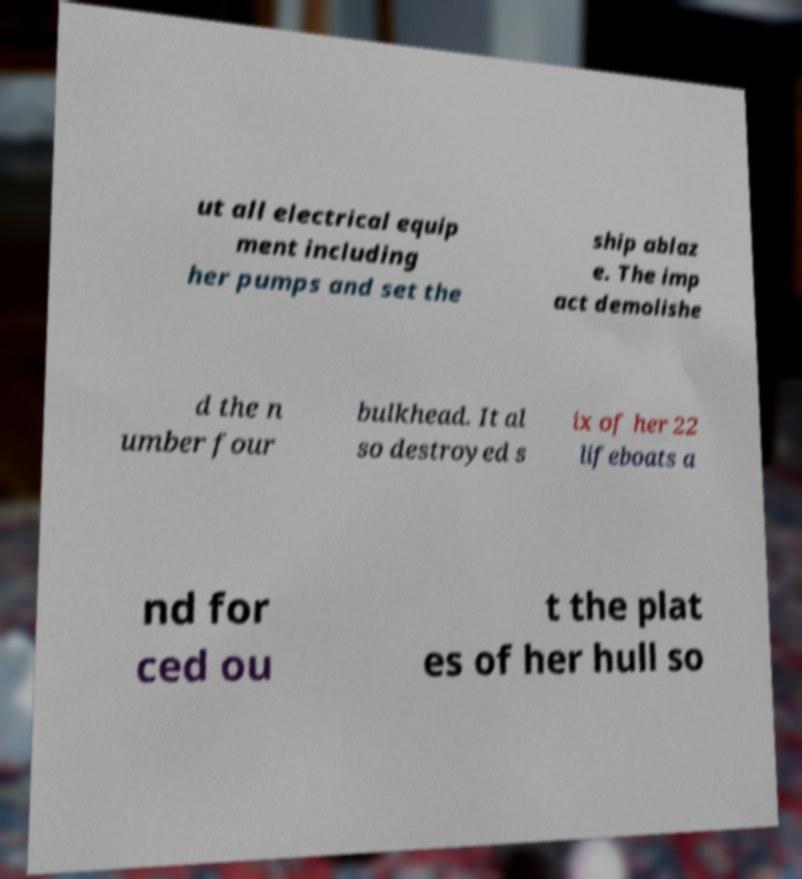Can you read and provide the text displayed in the image?This photo seems to have some interesting text. Can you extract and type it out for me? ut all electrical equip ment including her pumps and set the ship ablaz e. The imp act demolishe d the n umber four bulkhead. It al so destroyed s ix of her 22 lifeboats a nd for ced ou t the plat es of her hull so 